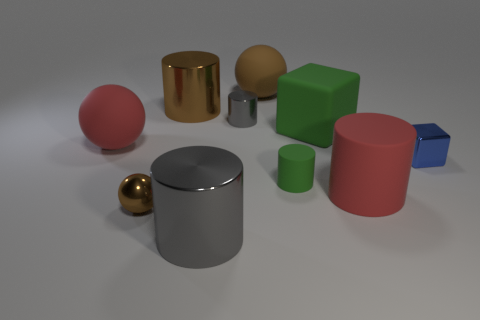Subtract all metallic spheres. How many spheres are left? 2 Subtract all blue balls. How many gray cylinders are left? 2 Subtract all brown cylinders. How many cylinders are left? 4 Subtract 3 cylinders. How many cylinders are left? 2 Subtract all balls. How many objects are left? 7 Add 4 metal cylinders. How many metal cylinders are left? 7 Add 5 blue metallic things. How many blue metallic things exist? 6 Subtract 0 purple blocks. How many objects are left? 10 Subtract all purple cylinders. Subtract all red spheres. How many cylinders are left? 5 Subtract all large gray cubes. Subtract all small blocks. How many objects are left? 9 